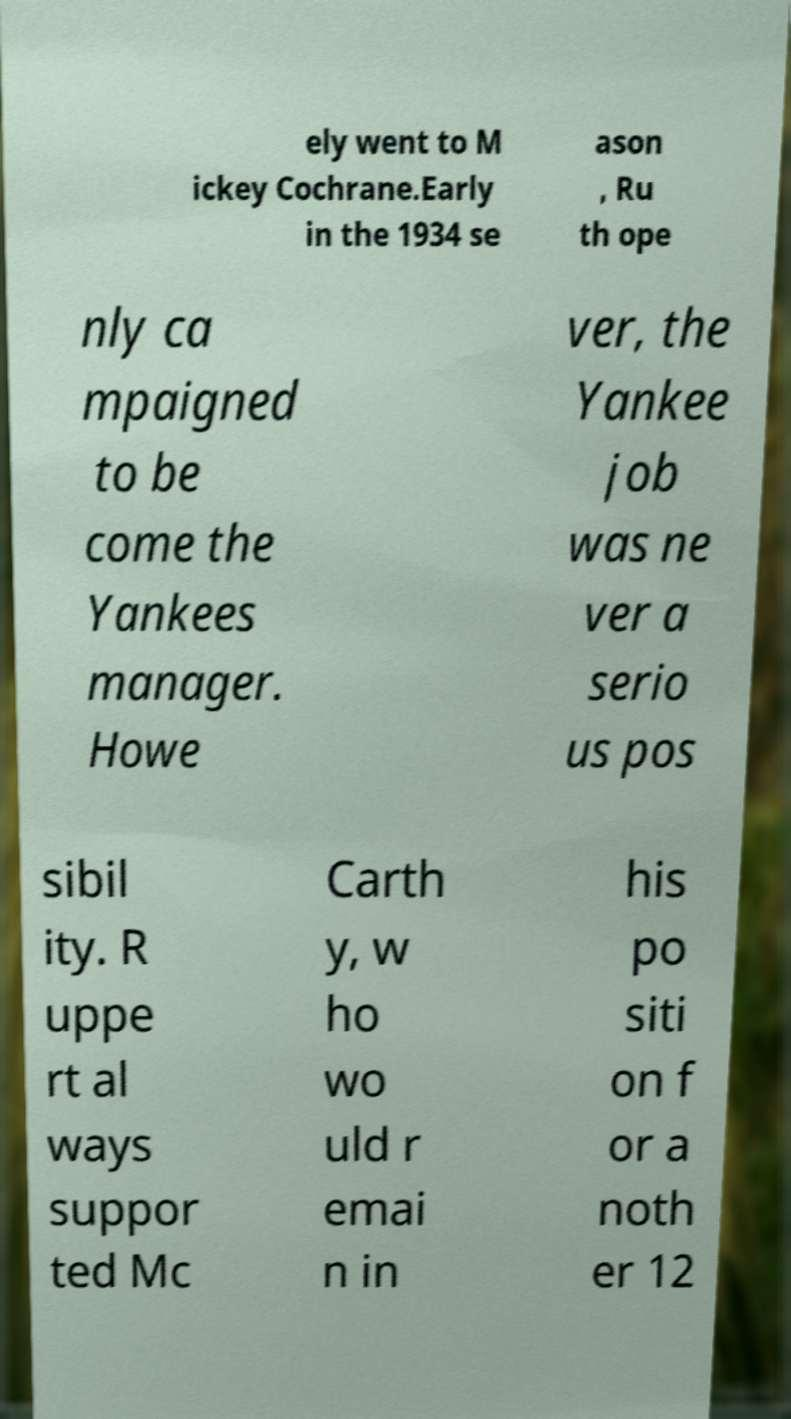What messages or text are displayed in this image? I need them in a readable, typed format. ely went to M ickey Cochrane.Early in the 1934 se ason , Ru th ope nly ca mpaigned to be come the Yankees manager. Howe ver, the Yankee job was ne ver a serio us pos sibil ity. R uppe rt al ways suppor ted Mc Carth y, w ho wo uld r emai n in his po siti on f or a noth er 12 